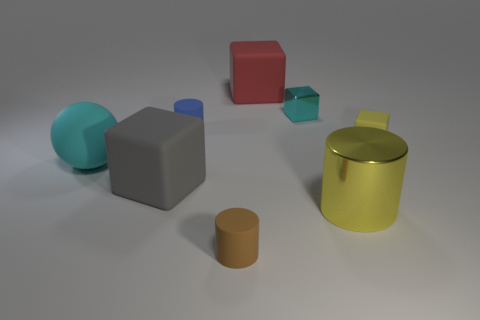How do the textures and materials in this scene interact with the lighting? The textures and materials greatly influence how light interacts within the scene. The metal objects, particularly the gold cylinder, have reflective surfaces that create highlights and mirror the environment. In contrast, the objects with matte surfaces, such as the red cube and the brown rubber cylinder, absorb the light, displaying diffused reflections and softer shadows, which create variance in visual texture. 